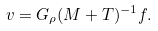Convert formula to latex. <formula><loc_0><loc_0><loc_500><loc_500>v = G _ { \rho } ( M + T ) ^ { - 1 } f .</formula> 